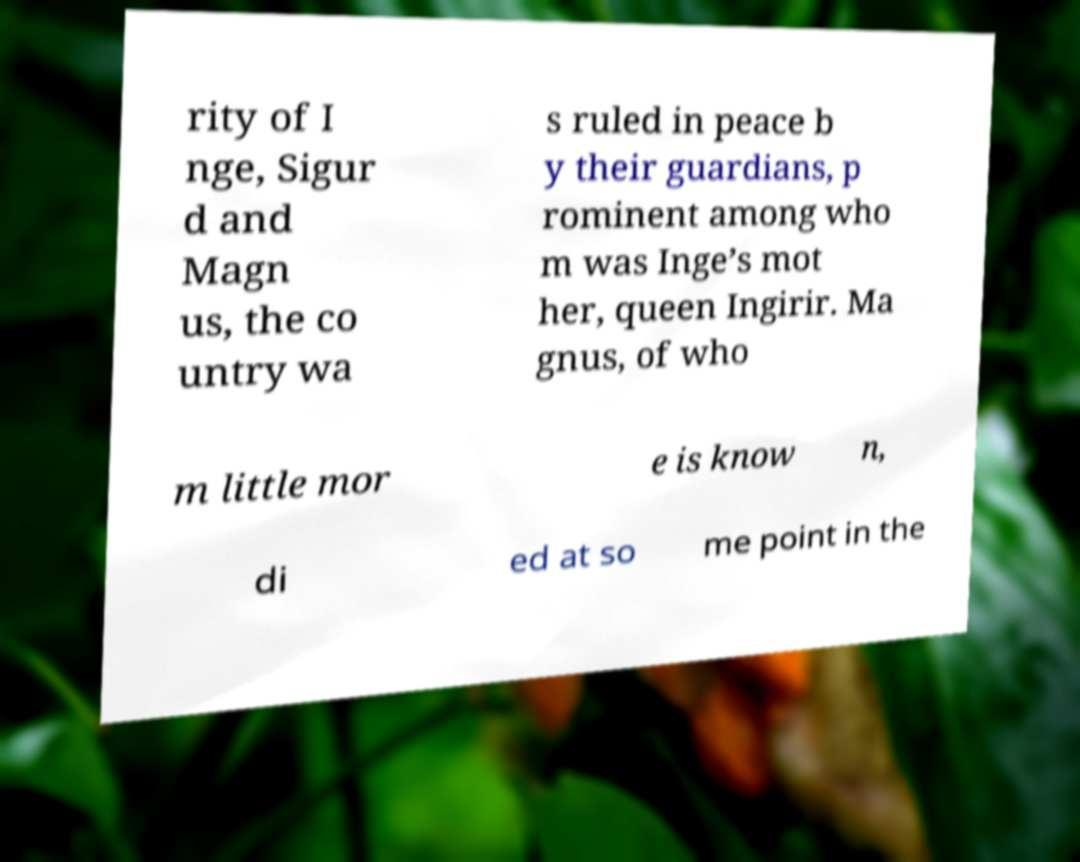Please identify and transcribe the text found in this image. rity of I nge, Sigur d and Magn us, the co untry wa s ruled in peace b y their guardians, p rominent among who m was Inge’s mot her, queen Ingirir. Ma gnus, of who m little mor e is know n, di ed at so me point in the 